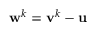<formula> <loc_0><loc_0><loc_500><loc_500>w ^ { k } = v ^ { k } - u</formula> 